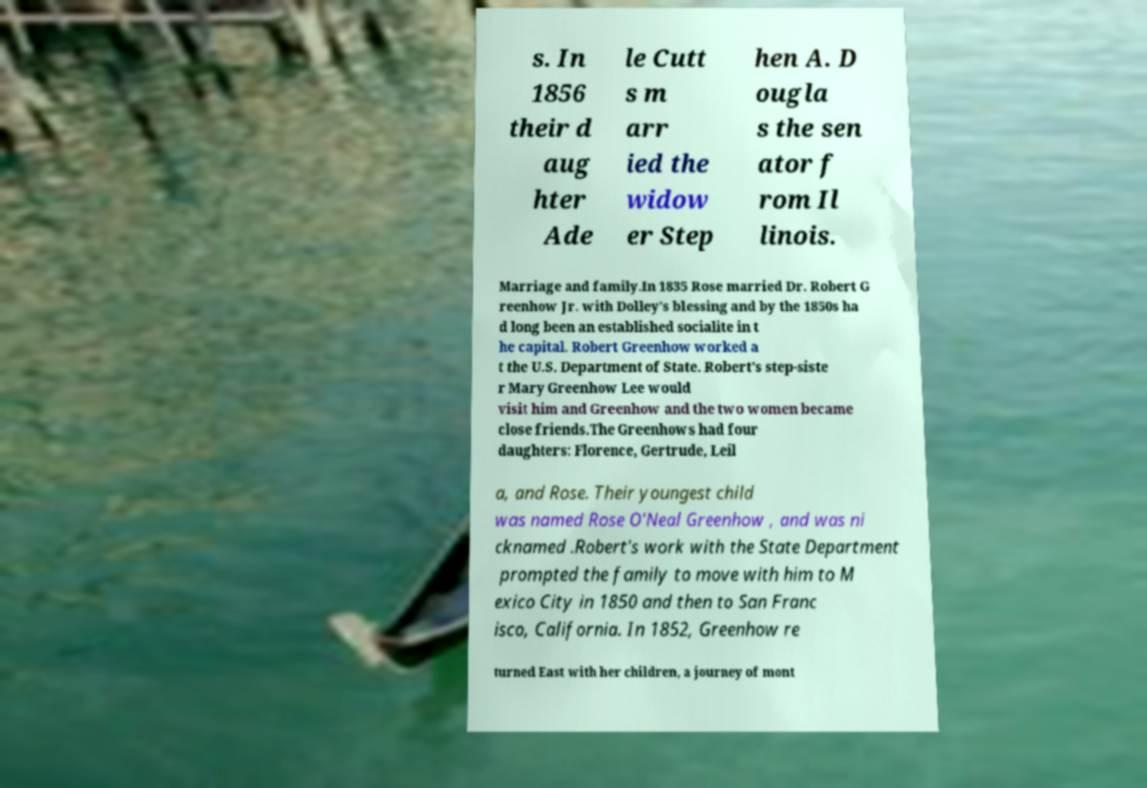Could you assist in decoding the text presented in this image and type it out clearly? s. In 1856 their d aug hter Ade le Cutt s m arr ied the widow er Step hen A. D ougla s the sen ator f rom Il linois. Marriage and family.In 1835 Rose married Dr. Robert G reenhow Jr. with Dolley's blessing and by the 1850s ha d long been an established socialite in t he capital. Robert Greenhow worked a t the U.S. Department of State. Robert's step-siste r Mary Greenhow Lee would visit him and Greenhow and the two women became close friends.The Greenhows had four daughters: Florence, Gertrude, Leil a, and Rose. Their youngest child was named Rose O'Neal Greenhow , and was ni cknamed .Robert's work with the State Department prompted the family to move with him to M exico City in 1850 and then to San Franc isco, California. In 1852, Greenhow re turned East with her children, a journey of mont 